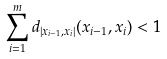<formula> <loc_0><loc_0><loc_500><loc_500>\sum _ { i = 1 } ^ { m } d _ { | x _ { i - 1 } , x _ { i } | } ( x _ { i - 1 } , x _ { i } ) < 1</formula> 